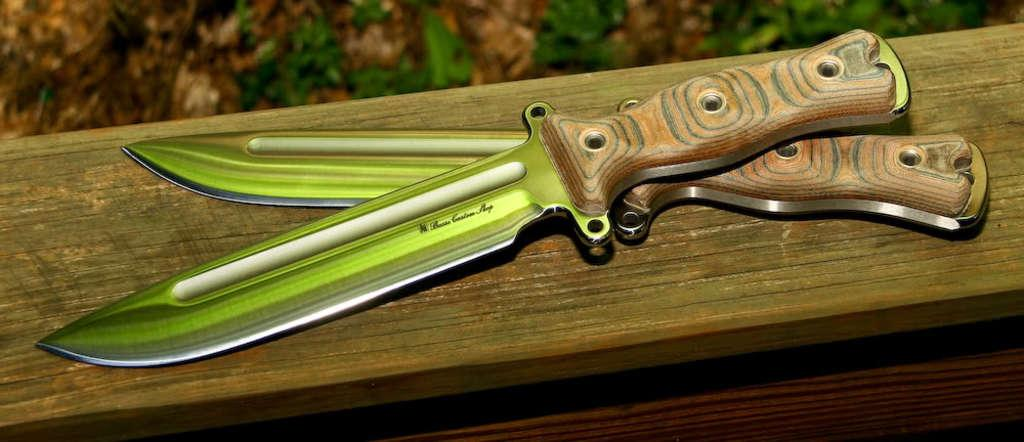How many knives are visible in the image? There are two knives in the image. Where are the knives located? The knives are on a wooden platform. What type of soap is being used to clean the knives in the image? There is no soap or cleaning activity depicted in the image; it only shows two knives on a wooden platform. 